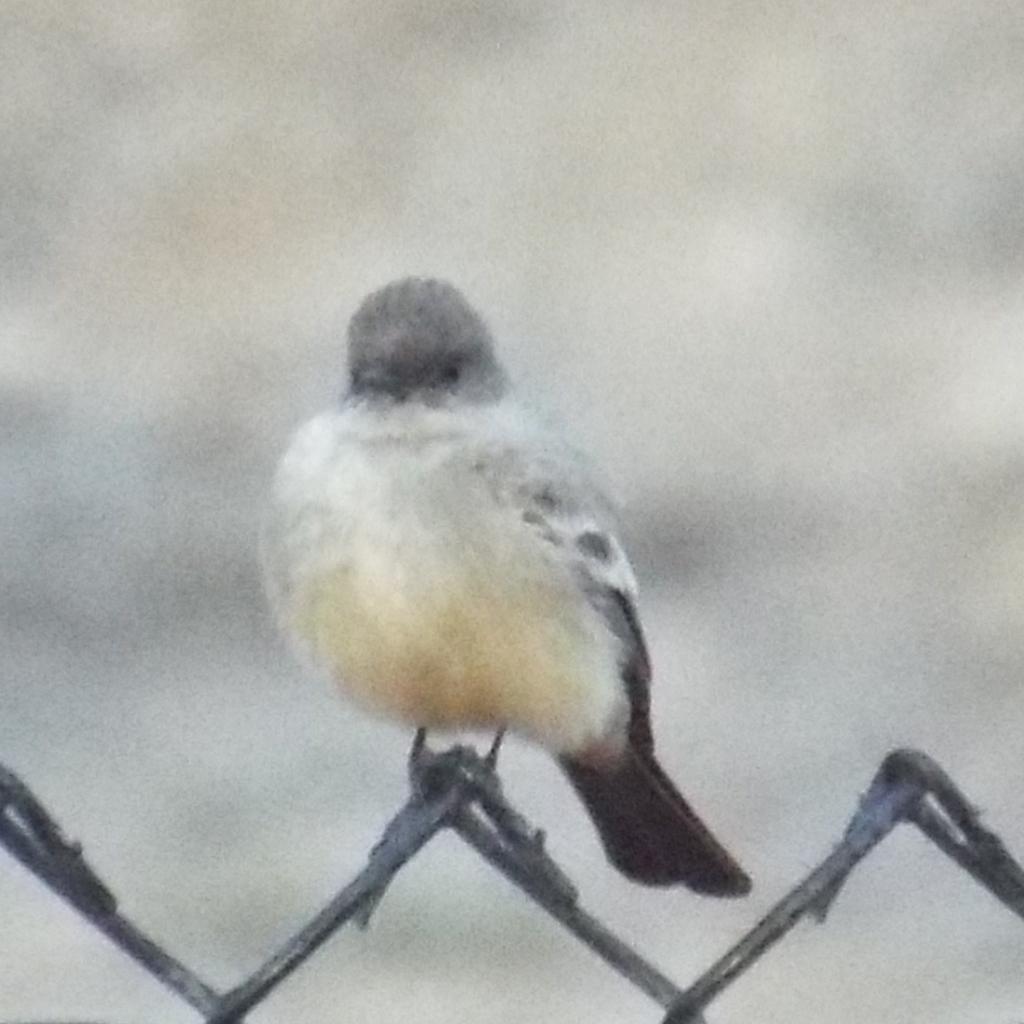Can you describe this image briefly? This image is taken outdoors. In this image the background is a little blurred. In the middle of the image there is a bird on the mesh. At the bottom of the image there is a mesh. 